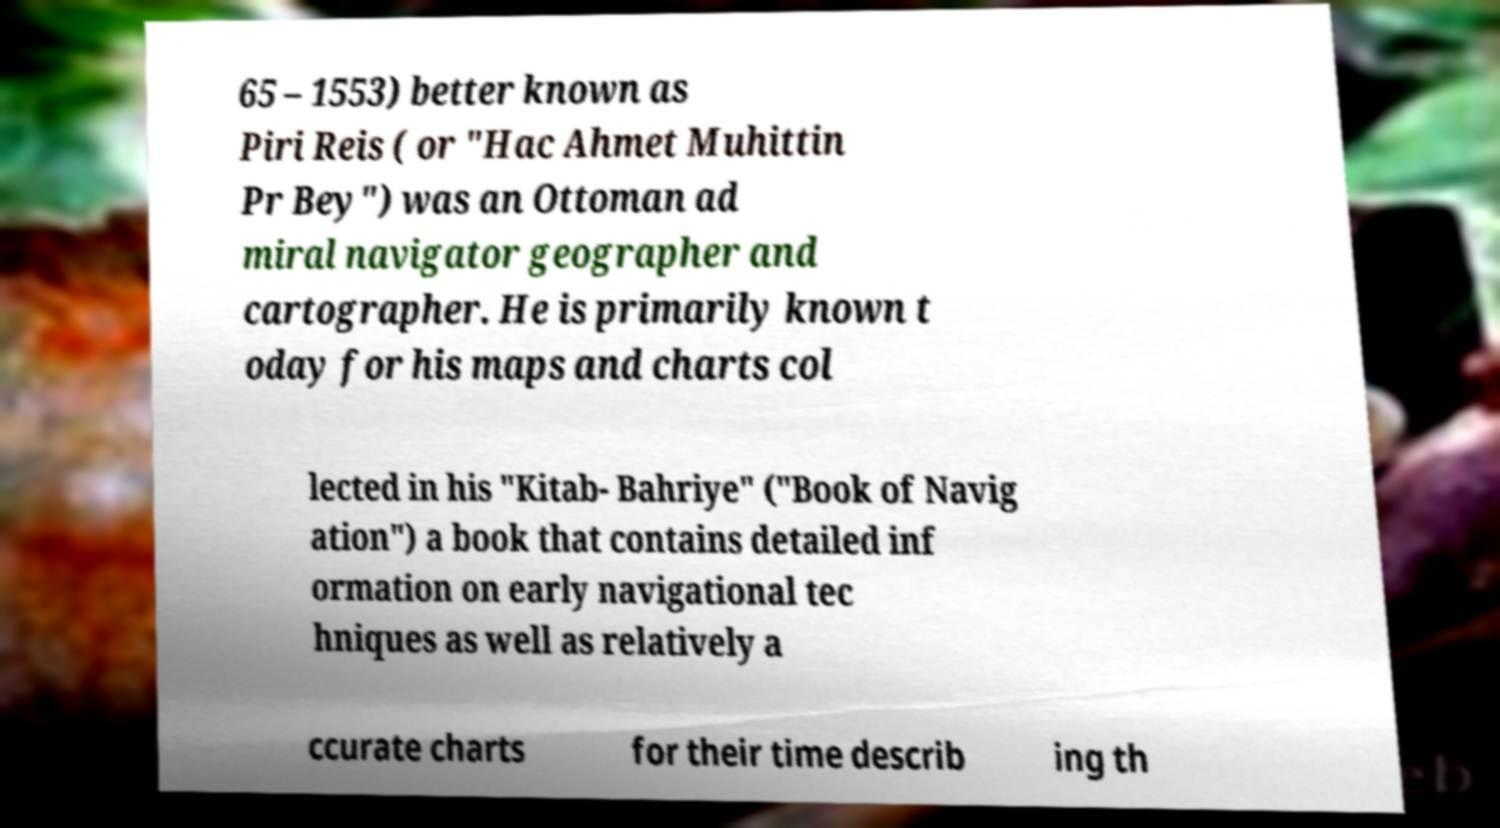Could you assist in decoding the text presented in this image and type it out clearly? 65 – 1553) better known as Piri Reis ( or "Hac Ahmet Muhittin Pr Bey") was an Ottoman ad miral navigator geographer and cartographer. He is primarily known t oday for his maps and charts col lected in his "Kitab- Bahriye" ("Book of Navig ation") a book that contains detailed inf ormation on early navigational tec hniques as well as relatively a ccurate charts for their time describ ing th 